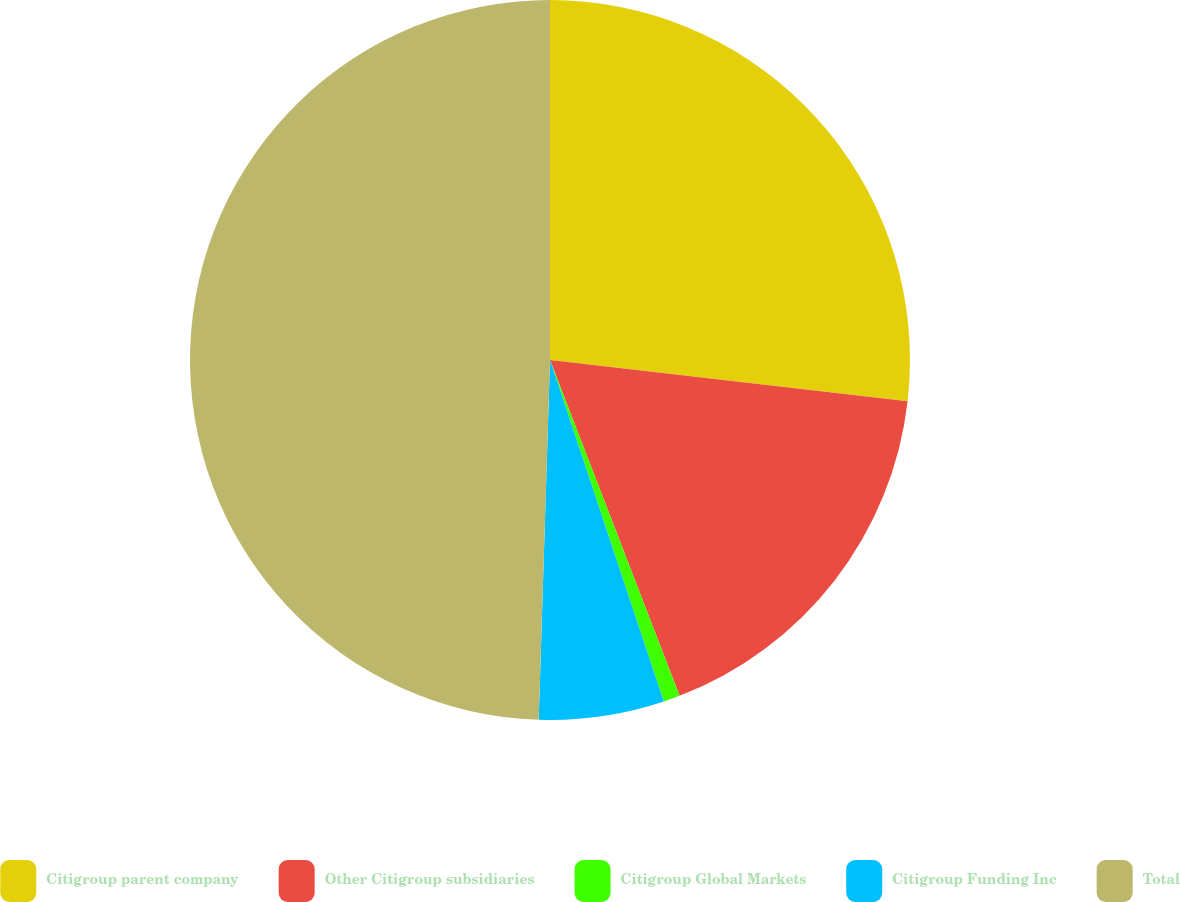Convert chart to OTSL. <chart><loc_0><loc_0><loc_500><loc_500><pie_chart><fcel>Citigroup parent company<fcel>Other Citigroup subsidiaries<fcel>Citigroup Global Markets<fcel>Citigroup Funding Inc<fcel>Total<nl><fcel>26.83%<fcel>17.31%<fcel>0.74%<fcel>5.62%<fcel>49.5%<nl></chart> 